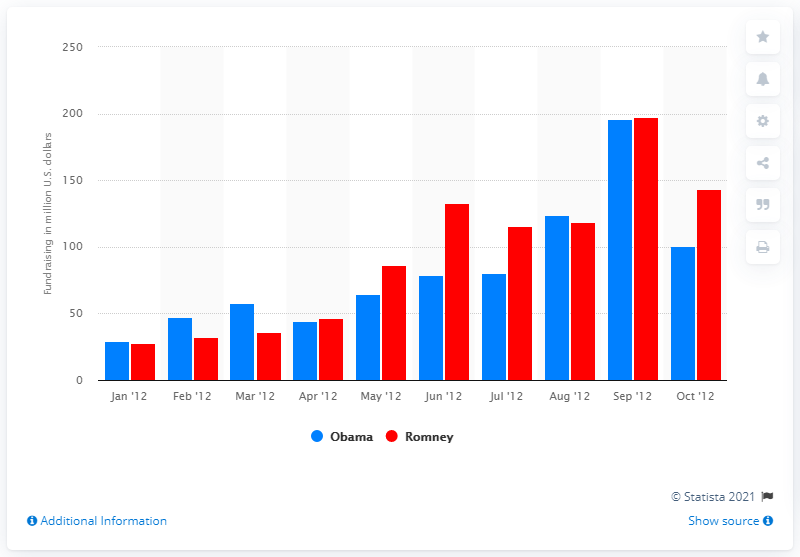Identify some key points in this picture. In August 2012, Barack Obama raised a significant amount of money. 